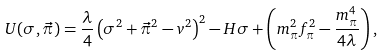<formula> <loc_0><loc_0><loc_500><loc_500>U ( \sigma , { \vec { \pi } } ) = \frac { \lambda } { 4 } \left ( \sigma ^ { 2 } + { \vec { \pi } } ^ { 2 } - v ^ { 2 } \right ) ^ { 2 } - H \sigma + \left ( m _ { \pi } ^ { 2 } f _ { \pi } ^ { 2 } - \frac { m _ { \pi } ^ { 4 } } { 4 \lambda } \right ) ,</formula> 